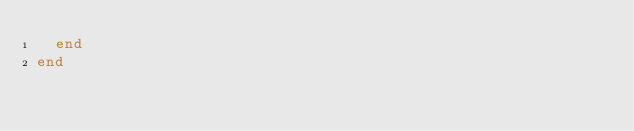Convert code to text. <code><loc_0><loc_0><loc_500><loc_500><_Ruby_>  end
end
</code> 